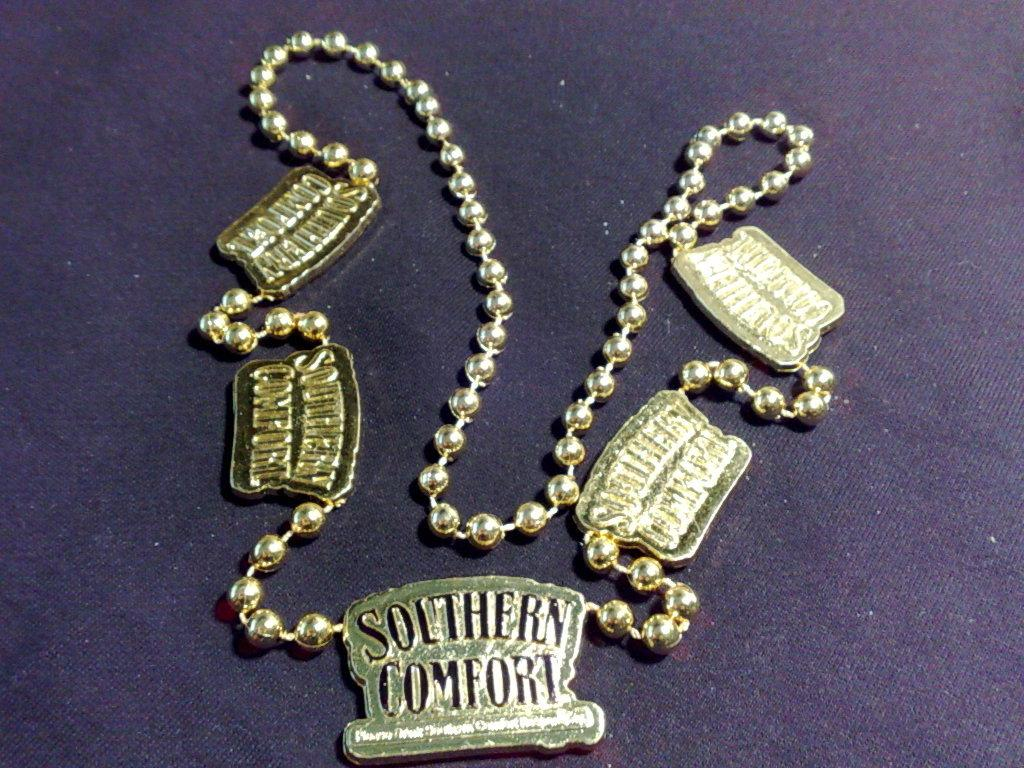<image>
Provide a brief description of the given image. Bracelet that has a charm which says SOUTHERN COMFORT on it. 